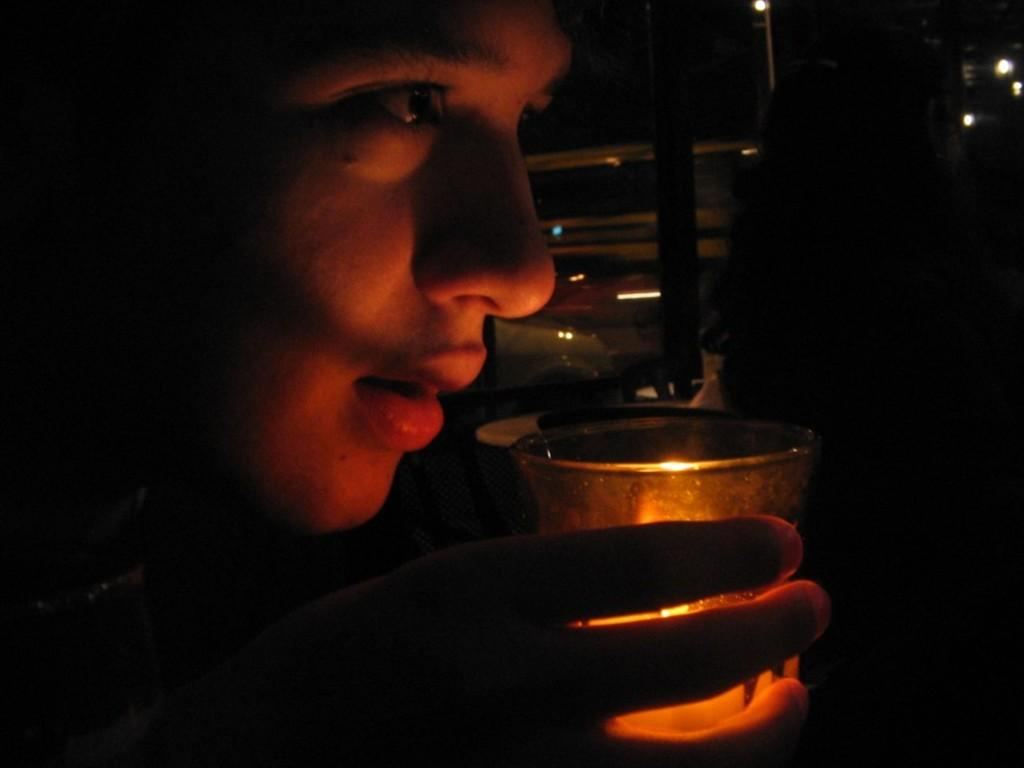Who or what is present in the image? There is a person in the image. What is the person holding in the image? The person is holding a candle in a glass. What can be seen in the background of the image? There are lights in the background of the image. What type of plastic material is used to make the moon in the image? There is no moon present in the image, so it is not possible to determine what type of plastic material might be used. 